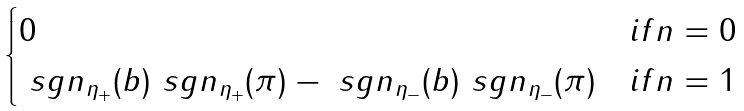Convert formula to latex. <formula><loc_0><loc_0><loc_500><loc_500>\begin{cases} 0 & i f n = 0 \\ \ s g n _ { \eta _ { + } } ( b ) \ s g n _ { \eta _ { + } } ( \pi ) - \ s g n _ { \eta _ { - } } ( b ) \ s g n _ { \eta _ { - } } ( \pi ) & i f n = 1 \\ \end{cases}</formula> 